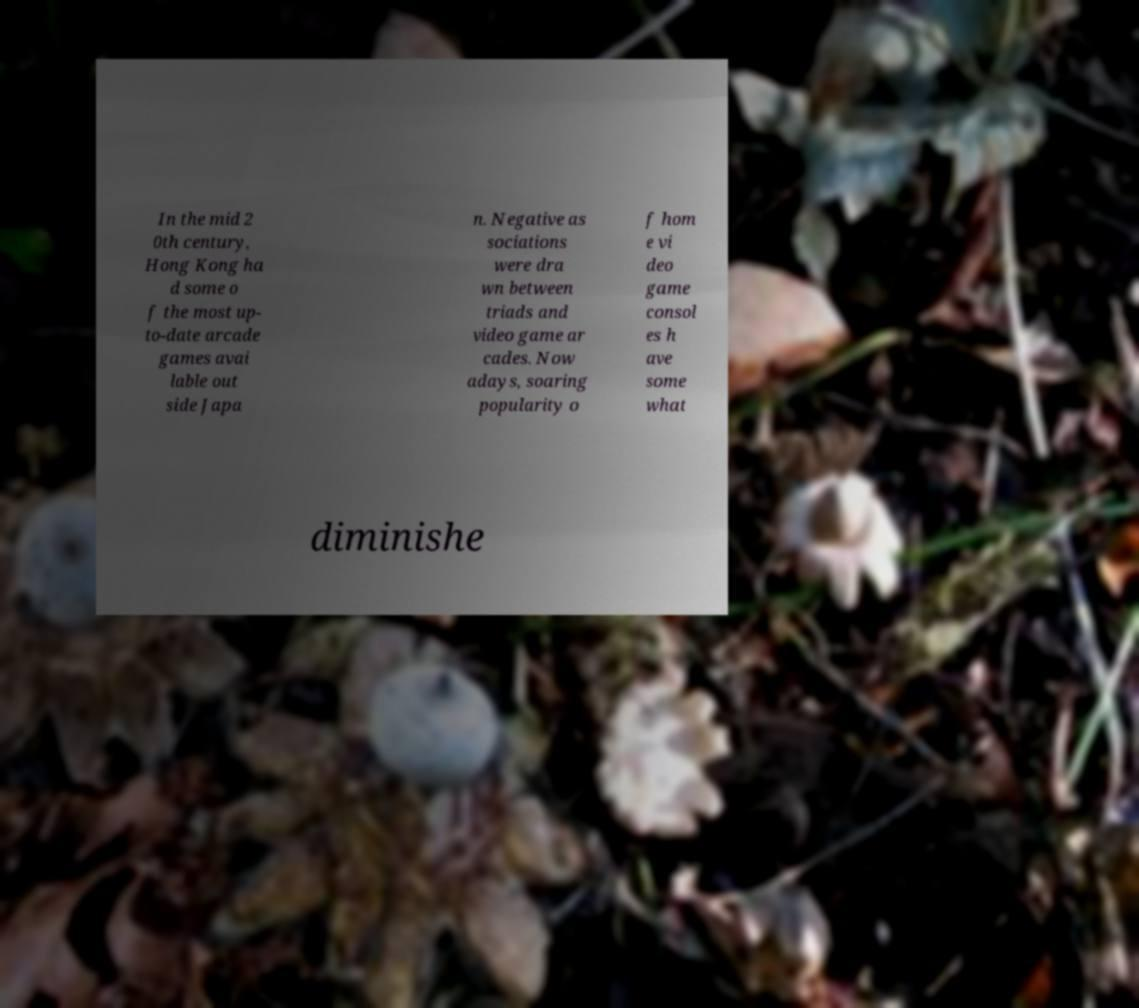Could you assist in decoding the text presented in this image and type it out clearly? In the mid 2 0th century, Hong Kong ha d some o f the most up- to-date arcade games avai lable out side Japa n. Negative as sociations were dra wn between triads and video game ar cades. Now adays, soaring popularity o f hom e vi deo game consol es h ave some what diminishe 